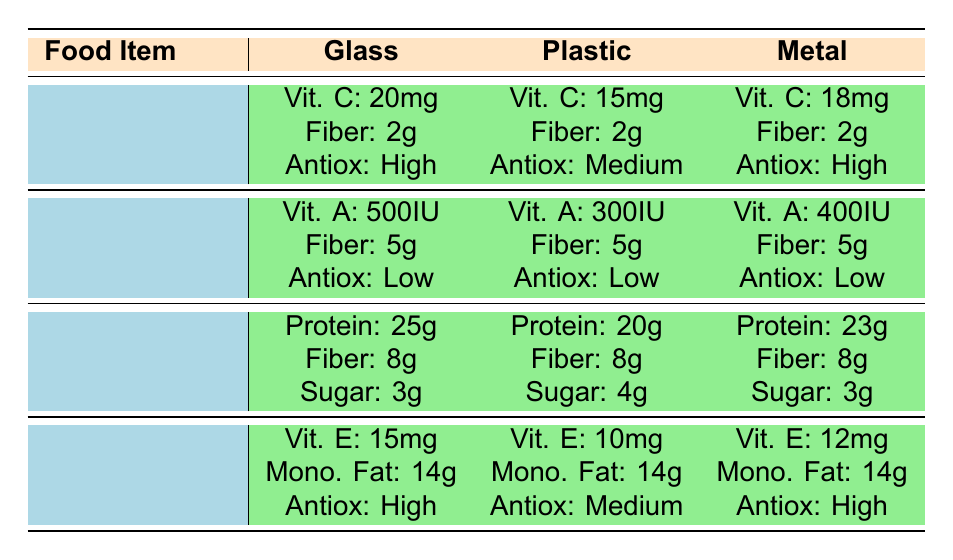What is the vitamin C content in Tomato Sauce packaged in glass? The table shows that the vitamin C content in Tomato Sauce packaged in glass is listed as 20mg.
Answer: 20mg Which packaging type for Tomato Sauce has the highest vitamin C content? Comparing the vitamin C content across the packaging types for Tomato Sauce, glass has 20mg, metal has 18mg, and plastic has 15mg. Glass has the highest.
Answer: Glass How much fiber is present in Canned Peas across all packaging types? The fiber content in Canned Peas is consistent across all types: glass, plastic, and metal all have 5g of fiber.
Answer: 5g Is the antioxidant level in Olive Oil lower in plastic packaging compared to glass and metal? According to the table, glass and metal packaging for Olive Oil both have high antioxidant levels while plastic has a medium level. Therefore, yes, it is lower in plastic.
Answer: Yes What is the difference in vitamin A content between Glass and Plastic packaging for Canned Peas? The vitamin A content is 500IU for glass and 300IU for plastic. The difference is calculated as 500IU - 300IU = 200IU.
Answer: 200IU What is the average vitamin E content for Olive Oil across the different packaging types? The vitamin E values for the different packaging types are: glass 15mg, plastic 10mg, and metal 12mg. The average is calculated as (15 + 10 + 12)/3 = 12.33mg.
Answer: 12.33mg Does the Peanut Butter in glass packaging have more protein than in plastic packaging? The table lists 25g of protein for glass packaging and 20g for plastic packaging. Since 25g is greater than 20g, the statement is true.
Answer: Yes What type of packaging provides the highest protein content for Peanut Butter? The protein content for glass is 25g, for plastic is 20g, and for metal is 23g. The highest is in glass packaging.
Answer: Glass Which food item has the highest antioxidant rating, and in what packaging? Reviewing the antioxidant ratings, Tomato Sauce and Olive Oil both have high ratings in their glass and metal packagings. Thus, two items share the same highest rating.
Answer: Tomato Sauce and Olive Oil in glass and metal respectively 